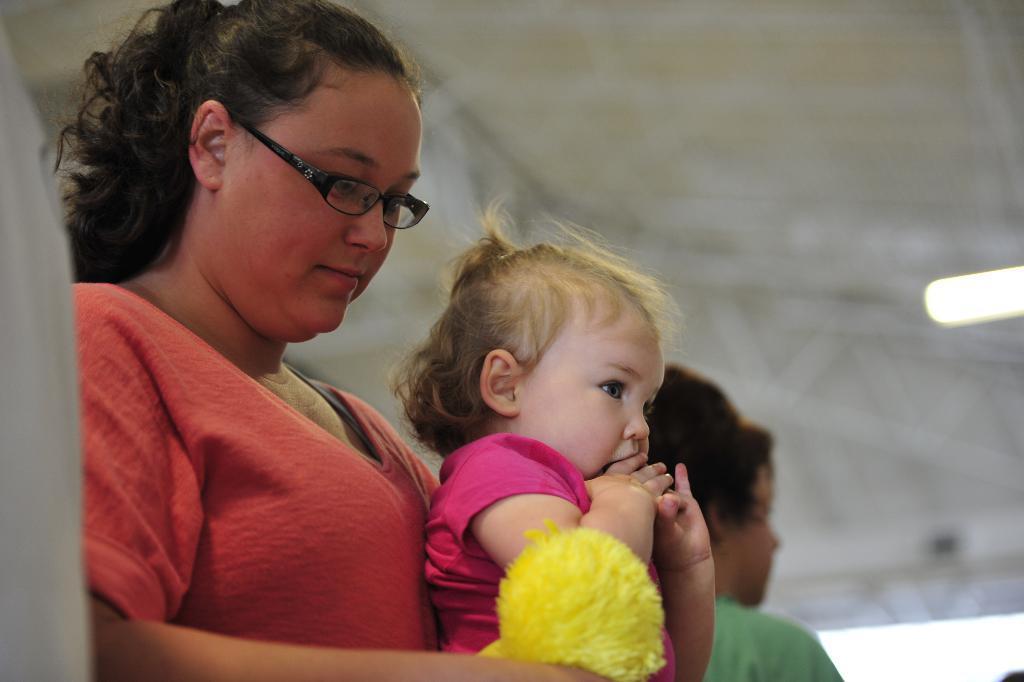Describe this image in one or two sentences. Here I can see a woman wearing a t-shirt and holding a baby and looking at the downwards. Beside her I can see another person. On the right side there is a light. 